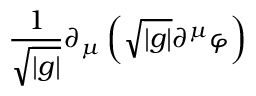Convert formula to latex. <formula><loc_0><loc_0><loc_500><loc_500>\frac { 1 } { \sqrt { | g | } } \partial _ { \mu } \left ( \sqrt { | g | } \partial ^ { \mu } \varphi \right )</formula> 